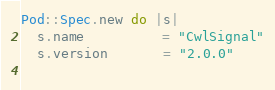Convert code to text. <code><loc_0><loc_0><loc_500><loc_500><_Ruby_>Pod::Spec.new do |s|
  s.name          = "CwlSignal"
  s.version       = "2.0.0"
  </code> 